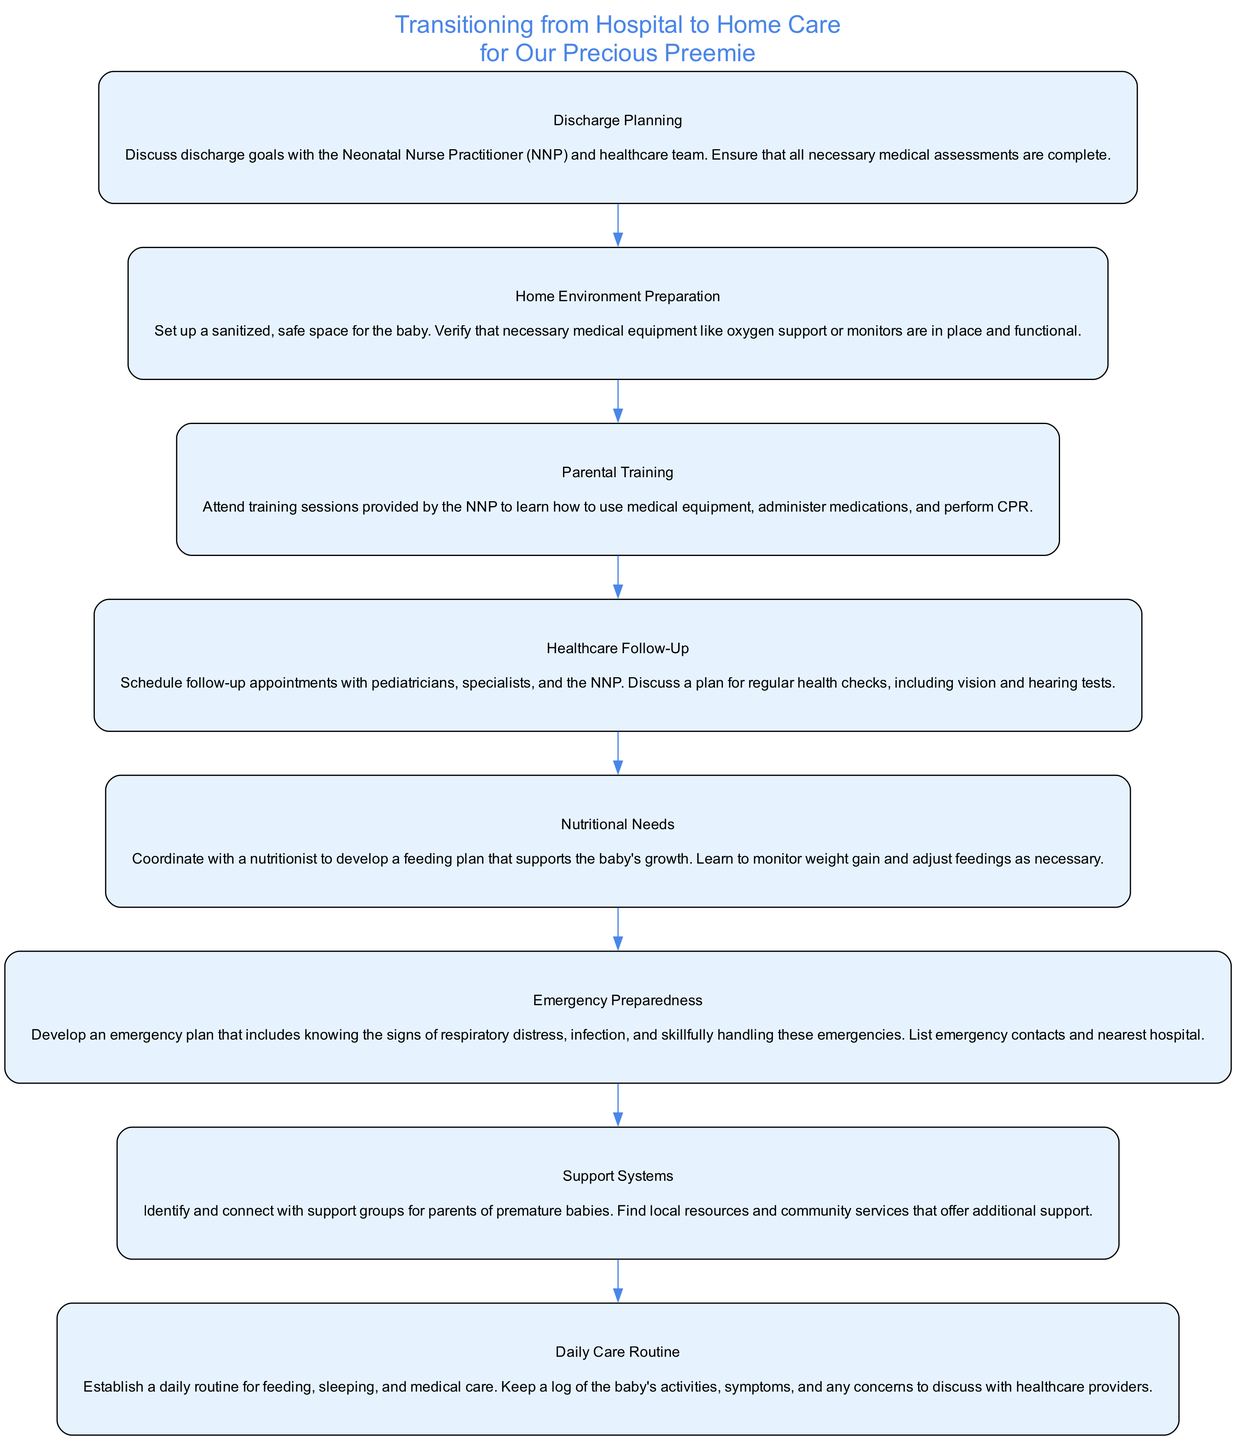What is the first step in the diagram? The diagram begins with "Discharge Planning," as it is the first node shown. It sets the stage for the other activities that follow.
Answer: Discharge Planning How many total nodes are in the diagram? By counting the individual elements, there are eight distinct nodes outlined in the diagram. Each node represents a critical step in the transition from hospital to home care.
Answer: 8 What is the title of the final step in the diagram? The last node represents the step titled "Daily Care Routine," which emphasizes the importance of establishing a daily care practice for the baby.
Answer: Daily Care Routine Which two steps are directly related by an edge? Observing the flow, the step "Parental Training" is directly connected to both "Discharge Planning" and "Healthcare Follow-Up," forming a flow through the chart.
Answer: Parental Training and Healthcare Follow-Up What is the focus of the "Home Environment Preparation" step? This step highlights the importance of creating a safe and sanitized space for the baby at home, ensuring essential medical equipment is ready and functional.
Answer: Sanitized, safe space Which element emphasizes the need for a support system? The step titled "Support Systems" specifically addresses the importance of connecting with support groups and community resources for parents.
Answer: Support Systems How does "Emergency Preparedness" relate to the other nodes? This step builds on the information from previous nodes, emphasizing readiness for emergencies by knowing signs of distress and preparing contingency plans.
Answer: Readiness for emergencies What is the purpose of the "Nutritional Needs" step? This node focuses on planning a feeding strategy to ensure proper growth and weight gain for the baby through coordination with a nutritionist.
Answer: Feeding plan for growth 